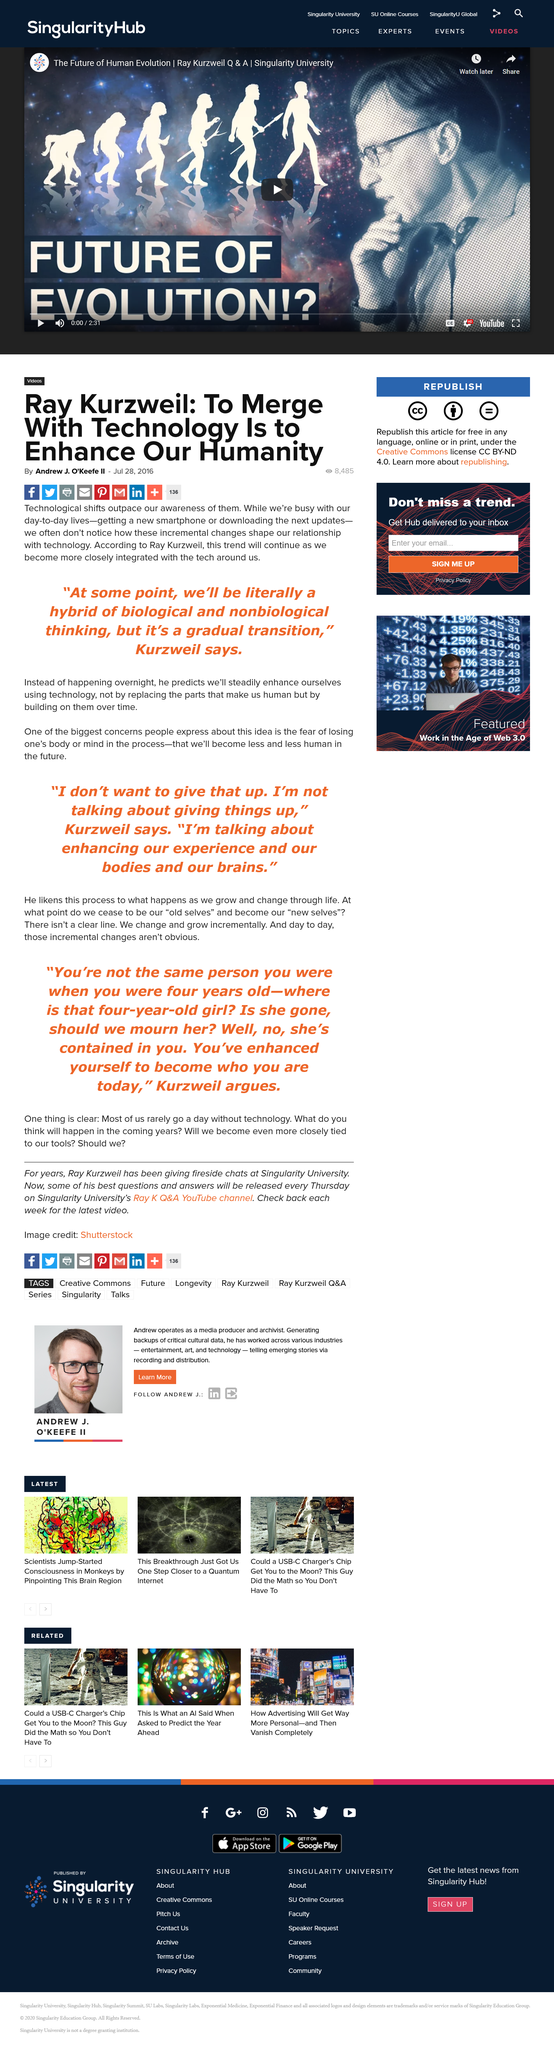Indicate a few pertinent items in this graphic. According to Ray Kurzweil, at some point in the future, we will become a hybrid of biological and nonbiological elements. Andrew J. O'Keefe II wrote the article and Ray Kurzweil is mentioned in the article. 